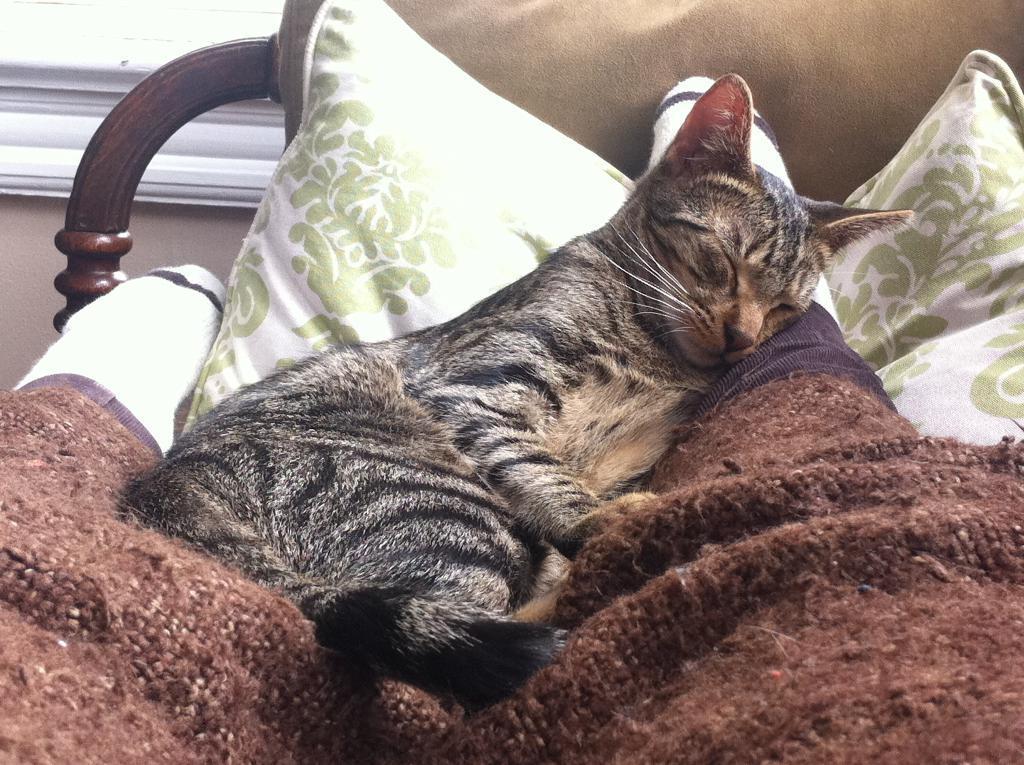Please provide a concise description of this image. In this image in the center there is one person's legs are visible, and on the person there is cat sleeping. And there is a blanket, pillows and bed, and in the background there is a window and wall. 